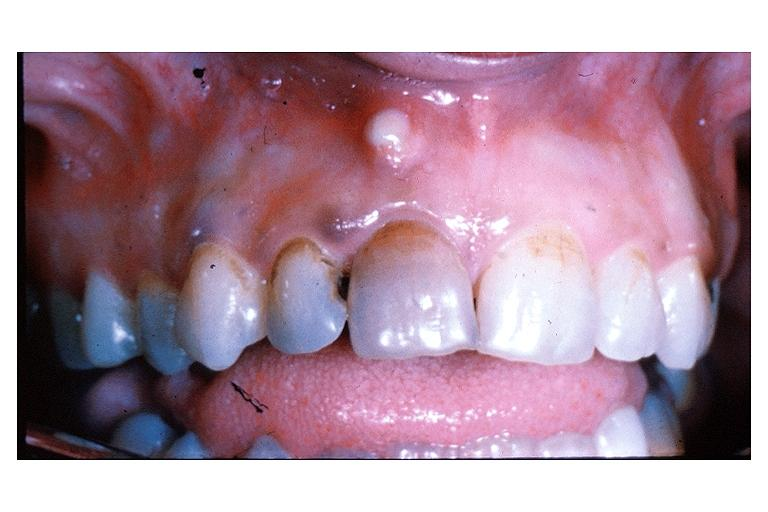s aorta present?
Answer the question using a single word or phrase. No 